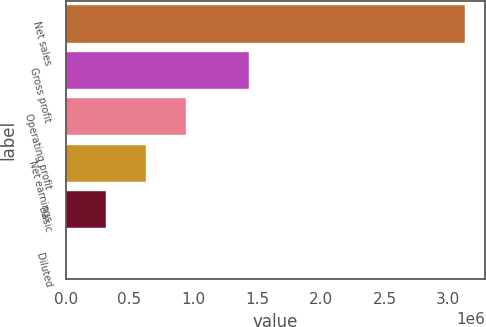Convert chart. <chart><loc_0><loc_0><loc_500><loc_500><bar_chart><fcel>Net sales<fcel>Gross profit<fcel>Operating profit<fcel>Net earnings<fcel>Basic<fcel>Diluted<nl><fcel>3.13289e+06<fcel>1.43838e+06<fcel>939868<fcel>626579<fcel>313290<fcel>0.8<nl></chart> 